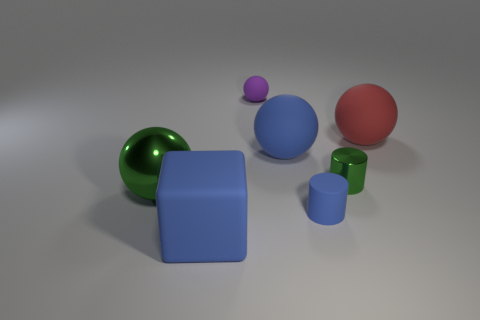Add 2 big blue matte objects. How many objects exist? 9 Subtract all green cylinders. How many cylinders are left? 1 Subtract all purple rubber spheres. How many spheres are left? 3 Subtract all balls. How many objects are left? 3 Subtract all purple objects. Subtract all big red balls. How many objects are left? 5 Add 3 tiny purple rubber objects. How many tiny purple rubber objects are left? 4 Add 4 cyan metallic balls. How many cyan metallic balls exist? 4 Subtract 1 green spheres. How many objects are left? 6 Subtract 2 cylinders. How many cylinders are left? 0 Subtract all gray balls. Subtract all yellow cubes. How many balls are left? 4 